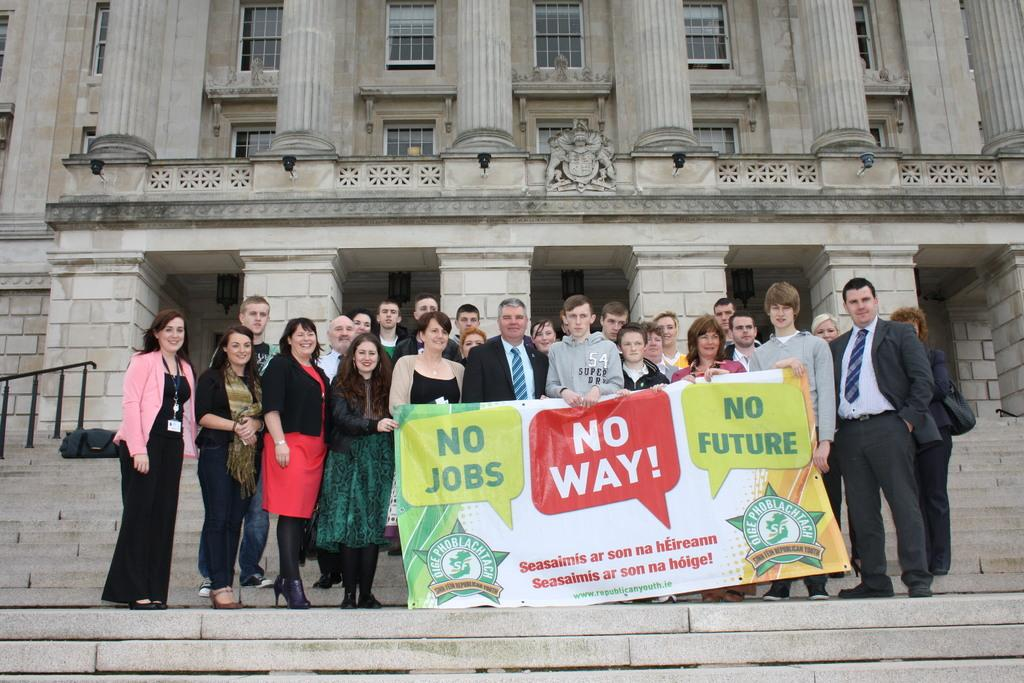What is happening in the image? There are people standing in the image. What can be seen hanging or displayed in the image? There is a banner in the image. What architectural feature is present in the foreground of the image? There are steps in the foreground of the image. What type of structure is visible in the background of the image? There is a building in the background of the image. What can be seen inside the building through the windows? There are windows with glasses in the building. What type of record is being played by the minister in the image? There is no minister or record present in the image. How does the whistle sound in the image? There is no whistle present in the image. 